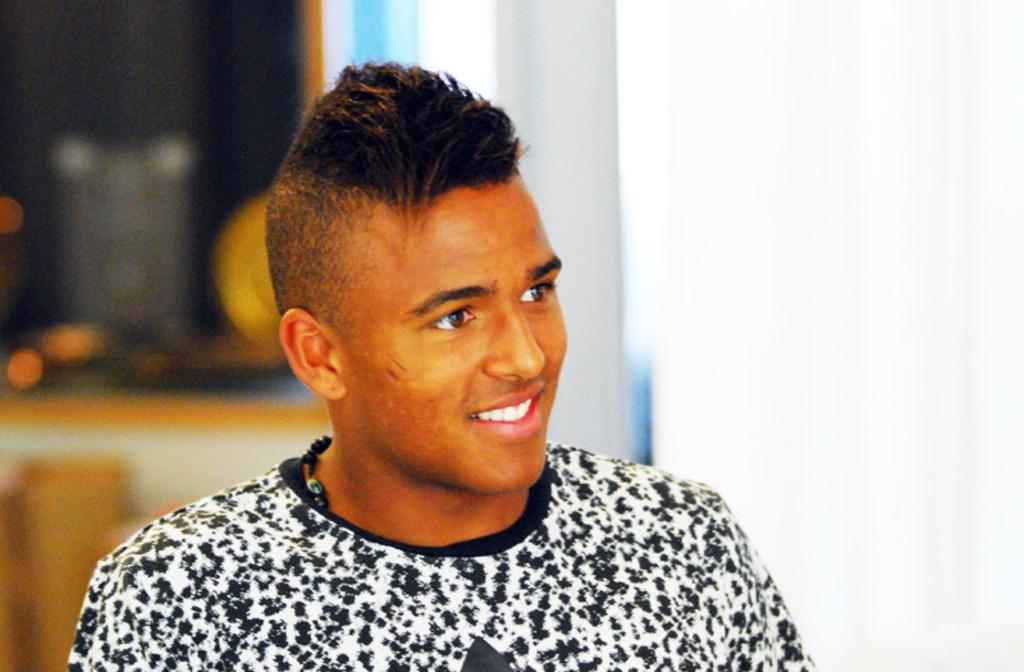What is the main subject of the image? There is a man in the image. What is the man's facial expression? The man is smiling. Can you describe the background of the image? The background of the image appears blurry. What type of underwear is the man wearing in the image? There is no information about the man's underwear in the image, so it cannot be determined. 